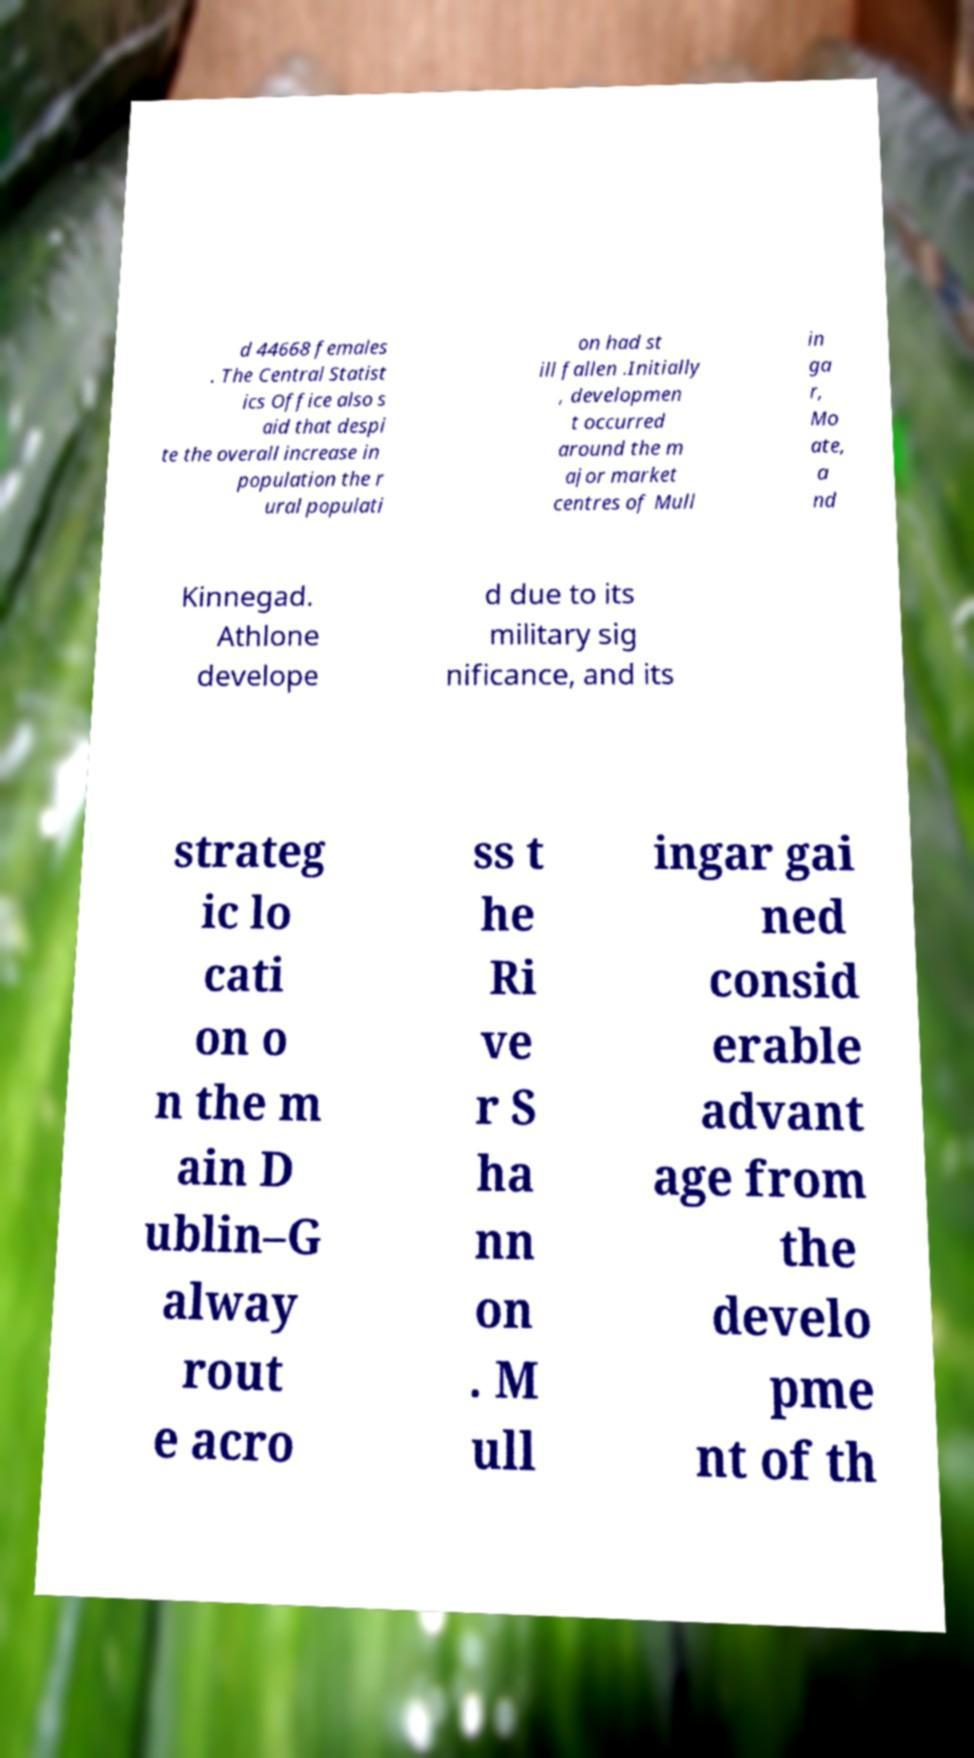There's text embedded in this image that I need extracted. Can you transcribe it verbatim? d 44668 females . The Central Statist ics Office also s aid that despi te the overall increase in population the r ural populati on had st ill fallen .Initially , developmen t occurred around the m ajor market centres of Mull in ga r, Mo ate, a nd Kinnegad. Athlone develope d due to its military sig nificance, and its strateg ic lo cati on o n the m ain D ublin–G alway rout e acro ss t he Ri ve r S ha nn on . M ull ingar gai ned consid erable advant age from the develo pme nt of th 